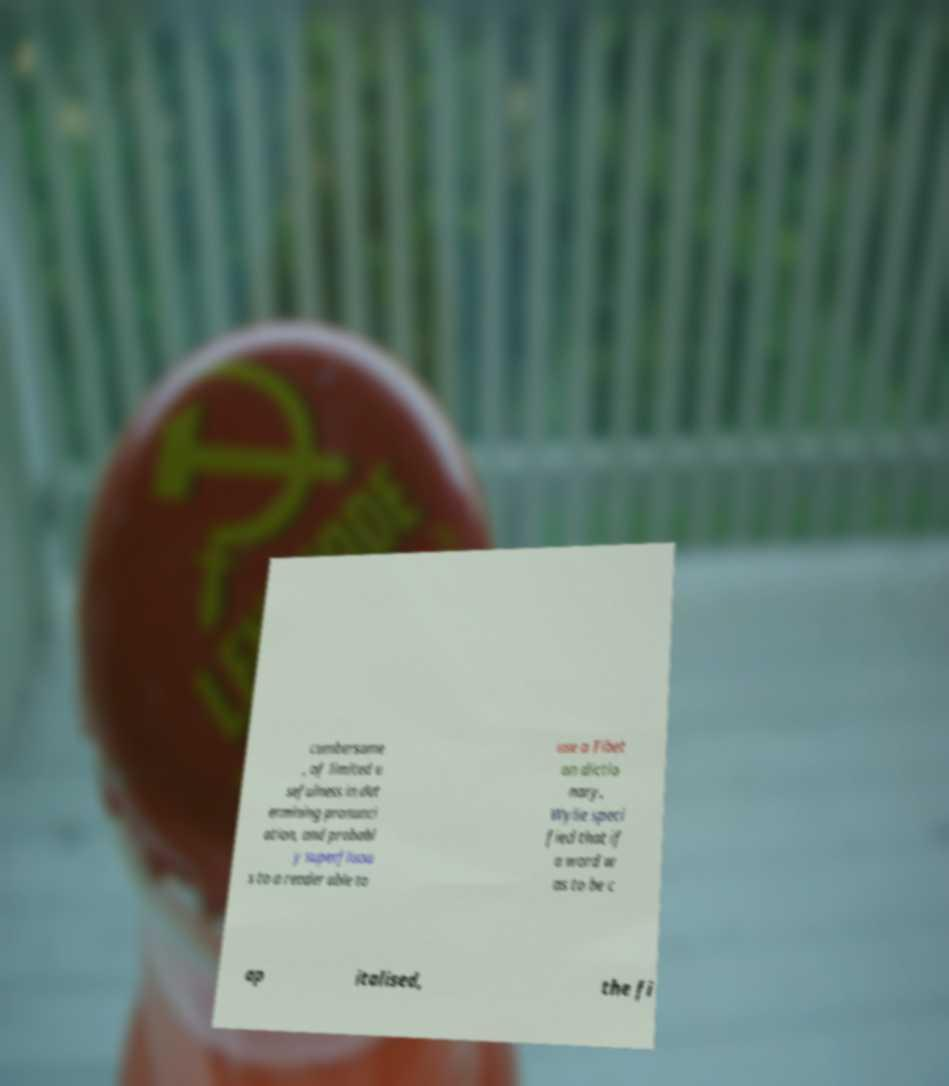For documentation purposes, I need the text within this image transcribed. Could you provide that? cumbersome , of limited u sefulness in det ermining pronunci ation, and probabl y superfluou s to a reader able to use a Tibet an dictio nary, Wylie speci fied that if a word w as to be c ap italised, the fi 